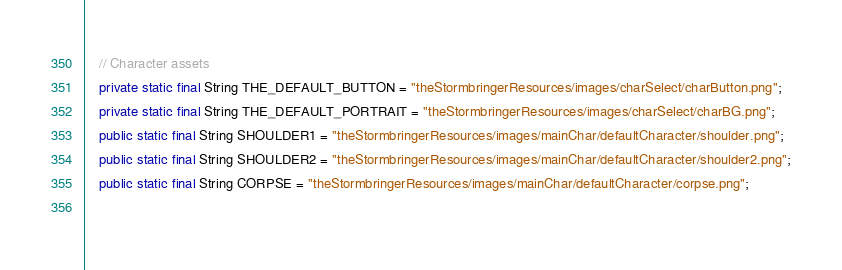<code> <loc_0><loc_0><loc_500><loc_500><_Java_>    // Character assets
    private static final String THE_DEFAULT_BUTTON = "theStormbringerResources/images/charSelect/charButton.png";
    private static final String THE_DEFAULT_PORTRAIT = "theStormbringerResources/images/charSelect/charBG.png";
    public static final String SHOULDER1 = "theStormbringerResources/images/mainChar/defaultCharacter/shoulder.png";
    public static final String SHOULDER2 = "theStormbringerResources/images/mainChar/defaultCharacter/shoulder2.png";
    public static final String CORPSE = "theStormbringerResources/images/mainChar/defaultCharacter/corpse.png";
    </code> 